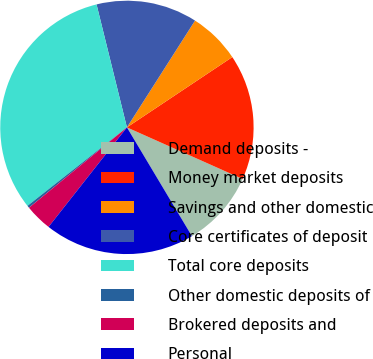<chart> <loc_0><loc_0><loc_500><loc_500><pie_chart><fcel>Demand deposits -<fcel>Money market deposits<fcel>Savings and other domestic<fcel>Core certificates of deposit<fcel>Total core deposits<fcel>Other domestic deposits of<fcel>Brokered deposits and<fcel>Personal<nl><fcel>9.75%<fcel>16.04%<fcel>6.6%<fcel>12.89%<fcel>31.78%<fcel>0.3%<fcel>3.45%<fcel>19.19%<nl></chart> 